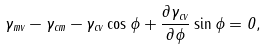<formula> <loc_0><loc_0><loc_500><loc_500>\gamma _ { m v } - \gamma _ { c m } - \gamma _ { c v } \cos { \phi } + \frac { \partial \gamma _ { c v } } { \partial \phi } \sin { \phi } = 0 ,</formula> 